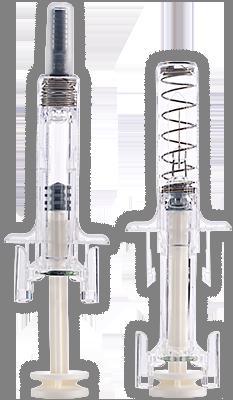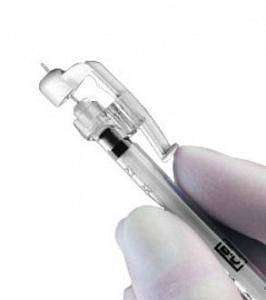The first image is the image on the left, the second image is the image on the right. Given the left and right images, does the statement "A total of two syringes are shown." hold true? Answer yes or no. No. 